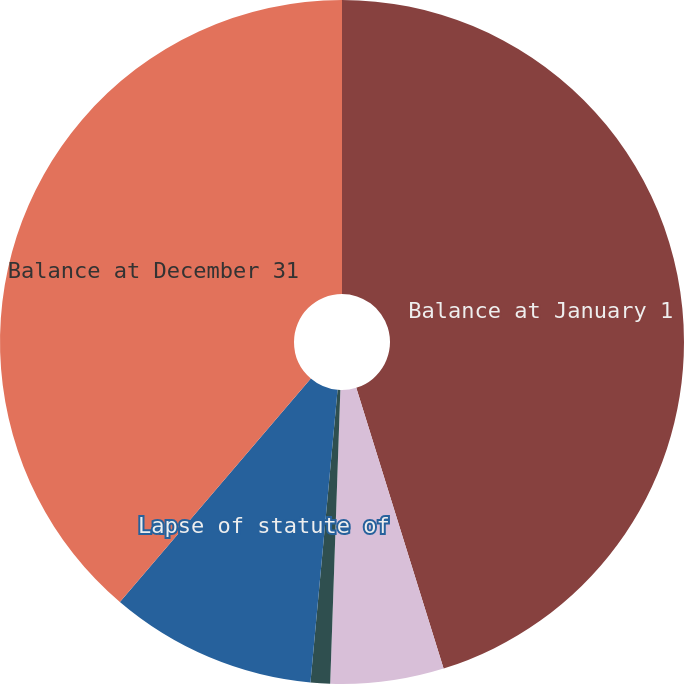<chart> <loc_0><loc_0><loc_500><loc_500><pie_chart><fcel>Balance at January 1<fcel>Additions based on tax<fcel>Accrued interest<fcel>Lapse of statute of<fcel>Balance at December 31<nl><fcel>45.2%<fcel>5.35%<fcel>0.92%<fcel>9.78%<fcel>38.75%<nl></chart> 